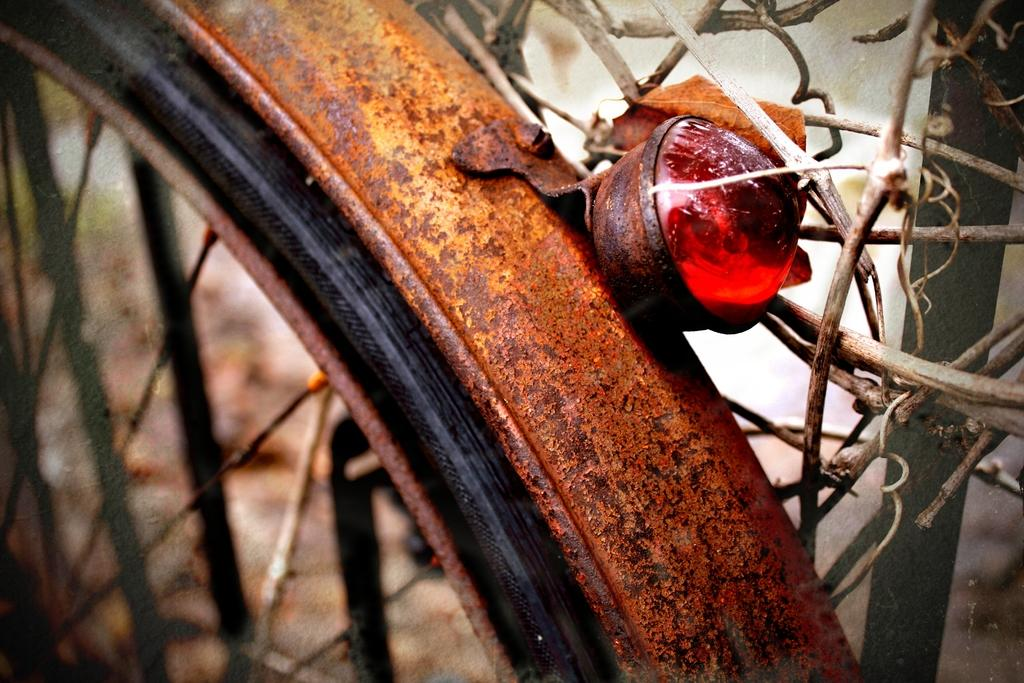What is the main object in the image? There is a wheel in the image. What color is the light visible at the back of the object? There is a red light at the back in the image. What type of pen is your dad using to write in the image? There is no pen or dad present in the image; it only features a wheel and a red light. 